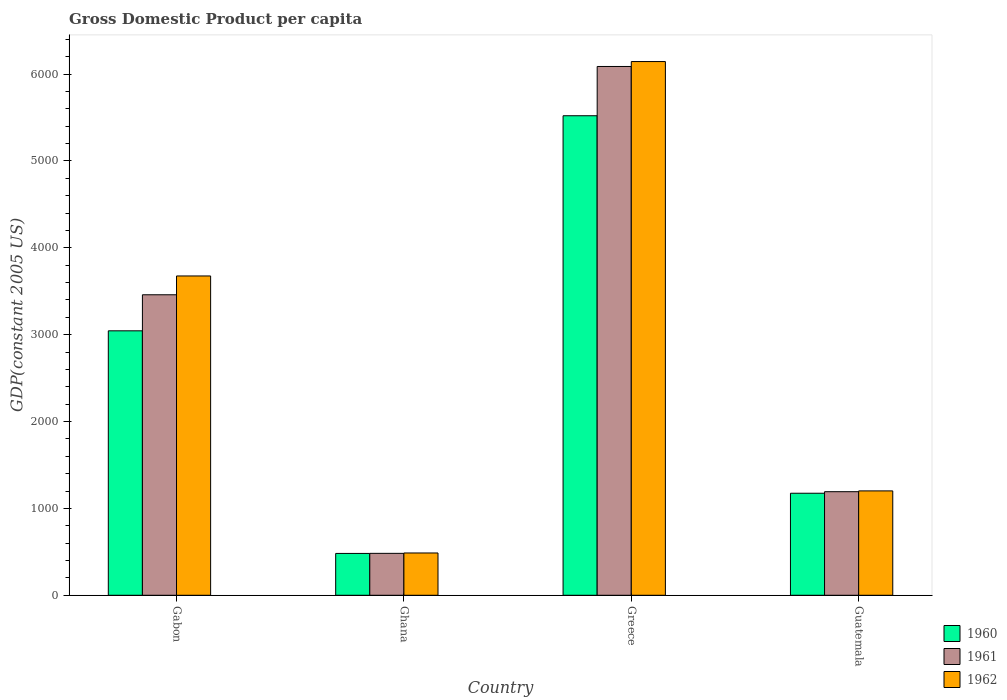How many different coloured bars are there?
Offer a very short reply. 3. Are the number of bars per tick equal to the number of legend labels?
Your answer should be very brief. Yes. Are the number of bars on each tick of the X-axis equal?
Provide a short and direct response. Yes. What is the label of the 4th group of bars from the left?
Offer a terse response. Guatemala. In how many cases, is the number of bars for a given country not equal to the number of legend labels?
Offer a very short reply. 0. What is the GDP per capita in 1961 in Gabon?
Provide a short and direct response. 3459.15. Across all countries, what is the maximum GDP per capita in 1961?
Make the answer very short. 6087.1. Across all countries, what is the minimum GDP per capita in 1961?
Your answer should be compact. 482.59. In which country was the GDP per capita in 1961 minimum?
Offer a very short reply. Ghana. What is the total GDP per capita in 1961 in the graph?
Keep it short and to the point. 1.12e+04. What is the difference between the GDP per capita in 1961 in Gabon and that in Greece?
Provide a succinct answer. -2627.95. What is the difference between the GDP per capita in 1962 in Ghana and the GDP per capita in 1960 in Guatemala?
Your response must be concise. -687.54. What is the average GDP per capita in 1960 per country?
Give a very brief answer. 2555.08. What is the difference between the GDP per capita of/in 1960 and GDP per capita of/in 1962 in Guatemala?
Offer a very short reply. -27.13. In how many countries, is the GDP per capita in 1961 greater than 800 US$?
Make the answer very short. 3. What is the ratio of the GDP per capita in 1960 in Gabon to that in Greece?
Ensure brevity in your answer.  0.55. What is the difference between the highest and the second highest GDP per capita in 1960?
Provide a short and direct response. 2475.93. What is the difference between the highest and the lowest GDP per capita in 1961?
Offer a terse response. 5604.5. In how many countries, is the GDP per capita in 1961 greater than the average GDP per capita in 1961 taken over all countries?
Provide a short and direct response. 2. What does the 2nd bar from the left in Greece represents?
Your answer should be compact. 1961. How many bars are there?
Your response must be concise. 12. Are all the bars in the graph horizontal?
Your answer should be compact. No. How many countries are there in the graph?
Make the answer very short. 4. Where does the legend appear in the graph?
Ensure brevity in your answer.  Bottom right. How are the legend labels stacked?
Offer a terse response. Vertical. What is the title of the graph?
Provide a succinct answer. Gross Domestic Product per capita. Does "1993" appear as one of the legend labels in the graph?
Provide a short and direct response. No. What is the label or title of the X-axis?
Provide a succinct answer. Country. What is the label or title of the Y-axis?
Ensure brevity in your answer.  GDP(constant 2005 US). What is the GDP(constant 2005 US) of 1960 in Gabon?
Your response must be concise. 3044.16. What is the GDP(constant 2005 US) in 1961 in Gabon?
Your answer should be compact. 3459.15. What is the GDP(constant 2005 US) in 1962 in Gabon?
Give a very brief answer. 3675.76. What is the GDP(constant 2005 US) of 1960 in Ghana?
Offer a terse response. 481.62. What is the GDP(constant 2005 US) of 1961 in Ghana?
Make the answer very short. 482.59. What is the GDP(constant 2005 US) in 1962 in Ghana?
Keep it short and to the point. 486.9. What is the GDP(constant 2005 US) in 1960 in Greece?
Provide a succinct answer. 5520.09. What is the GDP(constant 2005 US) in 1961 in Greece?
Ensure brevity in your answer.  6087.1. What is the GDP(constant 2005 US) of 1962 in Greece?
Offer a terse response. 6143.73. What is the GDP(constant 2005 US) in 1960 in Guatemala?
Offer a terse response. 1174.44. What is the GDP(constant 2005 US) of 1961 in Guatemala?
Make the answer very short. 1192.42. What is the GDP(constant 2005 US) in 1962 in Guatemala?
Your answer should be very brief. 1201.57. Across all countries, what is the maximum GDP(constant 2005 US) in 1960?
Make the answer very short. 5520.09. Across all countries, what is the maximum GDP(constant 2005 US) in 1961?
Make the answer very short. 6087.1. Across all countries, what is the maximum GDP(constant 2005 US) of 1962?
Provide a short and direct response. 6143.73. Across all countries, what is the minimum GDP(constant 2005 US) of 1960?
Your answer should be very brief. 481.62. Across all countries, what is the minimum GDP(constant 2005 US) of 1961?
Provide a succinct answer. 482.59. Across all countries, what is the minimum GDP(constant 2005 US) of 1962?
Provide a short and direct response. 486.9. What is the total GDP(constant 2005 US) in 1960 in the graph?
Give a very brief answer. 1.02e+04. What is the total GDP(constant 2005 US) in 1961 in the graph?
Make the answer very short. 1.12e+04. What is the total GDP(constant 2005 US) in 1962 in the graph?
Offer a very short reply. 1.15e+04. What is the difference between the GDP(constant 2005 US) in 1960 in Gabon and that in Ghana?
Provide a short and direct response. 2562.54. What is the difference between the GDP(constant 2005 US) of 1961 in Gabon and that in Ghana?
Your answer should be very brief. 2976.55. What is the difference between the GDP(constant 2005 US) of 1962 in Gabon and that in Ghana?
Your response must be concise. 3188.86. What is the difference between the GDP(constant 2005 US) in 1960 in Gabon and that in Greece?
Keep it short and to the point. -2475.93. What is the difference between the GDP(constant 2005 US) of 1961 in Gabon and that in Greece?
Ensure brevity in your answer.  -2627.95. What is the difference between the GDP(constant 2005 US) of 1962 in Gabon and that in Greece?
Your answer should be very brief. -2467.97. What is the difference between the GDP(constant 2005 US) in 1960 in Gabon and that in Guatemala?
Your answer should be very brief. 1869.72. What is the difference between the GDP(constant 2005 US) in 1961 in Gabon and that in Guatemala?
Offer a very short reply. 2266.73. What is the difference between the GDP(constant 2005 US) of 1962 in Gabon and that in Guatemala?
Your response must be concise. 2474.19. What is the difference between the GDP(constant 2005 US) of 1960 in Ghana and that in Greece?
Make the answer very short. -5038.47. What is the difference between the GDP(constant 2005 US) in 1961 in Ghana and that in Greece?
Your response must be concise. -5604.5. What is the difference between the GDP(constant 2005 US) of 1962 in Ghana and that in Greece?
Provide a succinct answer. -5656.83. What is the difference between the GDP(constant 2005 US) of 1960 in Ghana and that in Guatemala?
Offer a terse response. -692.82. What is the difference between the GDP(constant 2005 US) of 1961 in Ghana and that in Guatemala?
Provide a short and direct response. -709.82. What is the difference between the GDP(constant 2005 US) in 1962 in Ghana and that in Guatemala?
Ensure brevity in your answer.  -714.67. What is the difference between the GDP(constant 2005 US) in 1960 in Greece and that in Guatemala?
Your answer should be very brief. 4345.65. What is the difference between the GDP(constant 2005 US) in 1961 in Greece and that in Guatemala?
Keep it short and to the point. 4894.68. What is the difference between the GDP(constant 2005 US) of 1962 in Greece and that in Guatemala?
Give a very brief answer. 4942.16. What is the difference between the GDP(constant 2005 US) of 1960 in Gabon and the GDP(constant 2005 US) of 1961 in Ghana?
Ensure brevity in your answer.  2561.57. What is the difference between the GDP(constant 2005 US) in 1960 in Gabon and the GDP(constant 2005 US) in 1962 in Ghana?
Offer a terse response. 2557.26. What is the difference between the GDP(constant 2005 US) in 1961 in Gabon and the GDP(constant 2005 US) in 1962 in Ghana?
Your answer should be compact. 2972.24. What is the difference between the GDP(constant 2005 US) of 1960 in Gabon and the GDP(constant 2005 US) of 1961 in Greece?
Your answer should be compact. -3042.93. What is the difference between the GDP(constant 2005 US) in 1960 in Gabon and the GDP(constant 2005 US) in 1962 in Greece?
Provide a succinct answer. -3099.57. What is the difference between the GDP(constant 2005 US) in 1961 in Gabon and the GDP(constant 2005 US) in 1962 in Greece?
Your answer should be compact. -2684.59. What is the difference between the GDP(constant 2005 US) of 1960 in Gabon and the GDP(constant 2005 US) of 1961 in Guatemala?
Offer a terse response. 1851.75. What is the difference between the GDP(constant 2005 US) of 1960 in Gabon and the GDP(constant 2005 US) of 1962 in Guatemala?
Your answer should be very brief. 1842.59. What is the difference between the GDP(constant 2005 US) in 1961 in Gabon and the GDP(constant 2005 US) in 1962 in Guatemala?
Your response must be concise. 2257.57. What is the difference between the GDP(constant 2005 US) of 1960 in Ghana and the GDP(constant 2005 US) of 1961 in Greece?
Give a very brief answer. -5605.48. What is the difference between the GDP(constant 2005 US) of 1960 in Ghana and the GDP(constant 2005 US) of 1962 in Greece?
Offer a terse response. -5662.11. What is the difference between the GDP(constant 2005 US) in 1961 in Ghana and the GDP(constant 2005 US) in 1962 in Greece?
Your answer should be compact. -5661.14. What is the difference between the GDP(constant 2005 US) of 1960 in Ghana and the GDP(constant 2005 US) of 1961 in Guatemala?
Provide a succinct answer. -710.8. What is the difference between the GDP(constant 2005 US) in 1960 in Ghana and the GDP(constant 2005 US) in 1962 in Guatemala?
Your answer should be very brief. -719.96. What is the difference between the GDP(constant 2005 US) of 1961 in Ghana and the GDP(constant 2005 US) of 1962 in Guatemala?
Your answer should be very brief. -718.98. What is the difference between the GDP(constant 2005 US) of 1960 in Greece and the GDP(constant 2005 US) of 1961 in Guatemala?
Offer a terse response. 4327.67. What is the difference between the GDP(constant 2005 US) of 1960 in Greece and the GDP(constant 2005 US) of 1962 in Guatemala?
Offer a very short reply. 4318.51. What is the difference between the GDP(constant 2005 US) in 1961 in Greece and the GDP(constant 2005 US) in 1962 in Guatemala?
Offer a very short reply. 4885.52. What is the average GDP(constant 2005 US) in 1960 per country?
Give a very brief answer. 2555.08. What is the average GDP(constant 2005 US) of 1961 per country?
Make the answer very short. 2805.31. What is the average GDP(constant 2005 US) of 1962 per country?
Your response must be concise. 2876.99. What is the difference between the GDP(constant 2005 US) of 1960 and GDP(constant 2005 US) of 1961 in Gabon?
Keep it short and to the point. -414.98. What is the difference between the GDP(constant 2005 US) in 1960 and GDP(constant 2005 US) in 1962 in Gabon?
Your answer should be very brief. -631.6. What is the difference between the GDP(constant 2005 US) in 1961 and GDP(constant 2005 US) in 1962 in Gabon?
Give a very brief answer. -216.62. What is the difference between the GDP(constant 2005 US) in 1960 and GDP(constant 2005 US) in 1961 in Ghana?
Ensure brevity in your answer.  -0.97. What is the difference between the GDP(constant 2005 US) in 1960 and GDP(constant 2005 US) in 1962 in Ghana?
Your answer should be compact. -5.28. What is the difference between the GDP(constant 2005 US) in 1961 and GDP(constant 2005 US) in 1962 in Ghana?
Your response must be concise. -4.31. What is the difference between the GDP(constant 2005 US) of 1960 and GDP(constant 2005 US) of 1961 in Greece?
Make the answer very short. -567.01. What is the difference between the GDP(constant 2005 US) of 1960 and GDP(constant 2005 US) of 1962 in Greece?
Keep it short and to the point. -623.64. What is the difference between the GDP(constant 2005 US) of 1961 and GDP(constant 2005 US) of 1962 in Greece?
Provide a short and direct response. -56.63. What is the difference between the GDP(constant 2005 US) in 1960 and GDP(constant 2005 US) in 1961 in Guatemala?
Make the answer very short. -17.97. What is the difference between the GDP(constant 2005 US) in 1960 and GDP(constant 2005 US) in 1962 in Guatemala?
Offer a very short reply. -27.13. What is the difference between the GDP(constant 2005 US) in 1961 and GDP(constant 2005 US) in 1962 in Guatemala?
Ensure brevity in your answer.  -9.16. What is the ratio of the GDP(constant 2005 US) in 1960 in Gabon to that in Ghana?
Make the answer very short. 6.32. What is the ratio of the GDP(constant 2005 US) of 1961 in Gabon to that in Ghana?
Offer a very short reply. 7.17. What is the ratio of the GDP(constant 2005 US) in 1962 in Gabon to that in Ghana?
Offer a terse response. 7.55. What is the ratio of the GDP(constant 2005 US) of 1960 in Gabon to that in Greece?
Your response must be concise. 0.55. What is the ratio of the GDP(constant 2005 US) of 1961 in Gabon to that in Greece?
Provide a succinct answer. 0.57. What is the ratio of the GDP(constant 2005 US) in 1962 in Gabon to that in Greece?
Offer a very short reply. 0.6. What is the ratio of the GDP(constant 2005 US) in 1960 in Gabon to that in Guatemala?
Keep it short and to the point. 2.59. What is the ratio of the GDP(constant 2005 US) in 1961 in Gabon to that in Guatemala?
Offer a terse response. 2.9. What is the ratio of the GDP(constant 2005 US) in 1962 in Gabon to that in Guatemala?
Give a very brief answer. 3.06. What is the ratio of the GDP(constant 2005 US) of 1960 in Ghana to that in Greece?
Offer a terse response. 0.09. What is the ratio of the GDP(constant 2005 US) of 1961 in Ghana to that in Greece?
Keep it short and to the point. 0.08. What is the ratio of the GDP(constant 2005 US) in 1962 in Ghana to that in Greece?
Offer a terse response. 0.08. What is the ratio of the GDP(constant 2005 US) in 1960 in Ghana to that in Guatemala?
Offer a very short reply. 0.41. What is the ratio of the GDP(constant 2005 US) in 1961 in Ghana to that in Guatemala?
Ensure brevity in your answer.  0.4. What is the ratio of the GDP(constant 2005 US) of 1962 in Ghana to that in Guatemala?
Ensure brevity in your answer.  0.41. What is the ratio of the GDP(constant 2005 US) of 1960 in Greece to that in Guatemala?
Offer a very short reply. 4.7. What is the ratio of the GDP(constant 2005 US) in 1961 in Greece to that in Guatemala?
Your answer should be very brief. 5.1. What is the ratio of the GDP(constant 2005 US) of 1962 in Greece to that in Guatemala?
Give a very brief answer. 5.11. What is the difference between the highest and the second highest GDP(constant 2005 US) in 1960?
Keep it short and to the point. 2475.93. What is the difference between the highest and the second highest GDP(constant 2005 US) of 1961?
Offer a terse response. 2627.95. What is the difference between the highest and the second highest GDP(constant 2005 US) in 1962?
Provide a short and direct response. 2467.97. What is the difference between the highest and the lowest GDP(constant 2005 US) in 1960?
Offer a very short reply. 5038.47. What is the difference between the highest and the lowest GDP(constant 2005 US) of 1961?
Your answer should be compact. 5604.5. What is the difference between the highest and the lowest GDP(constant 2005 US) in 1962?
Keep it short and to the point. 5656.83. 